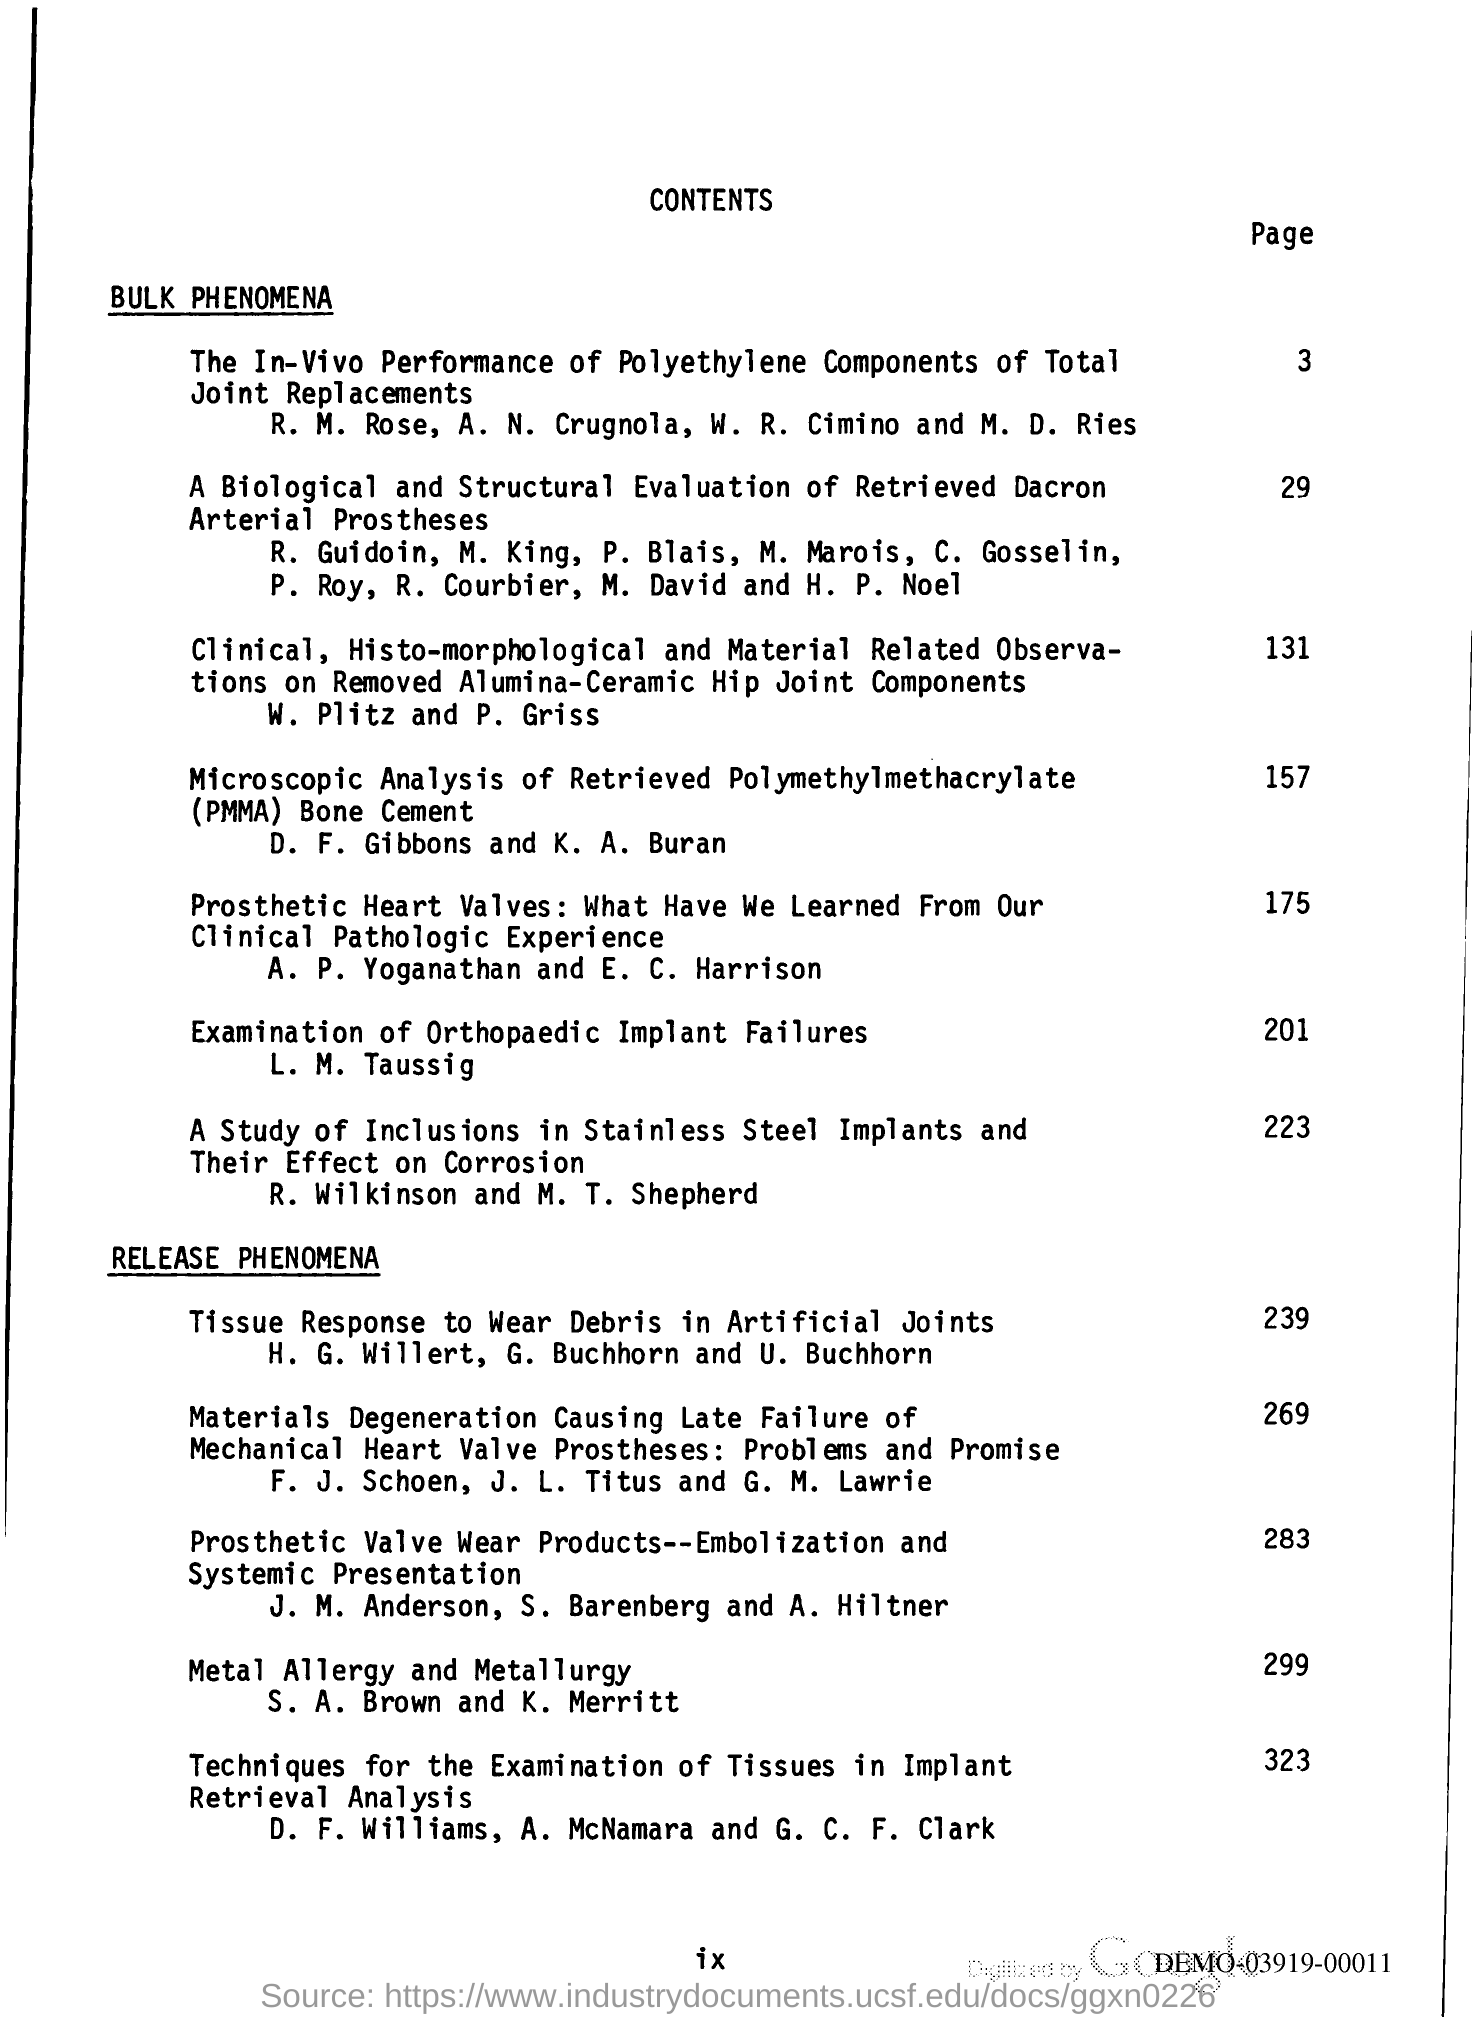What is the page number at which prosthetic heart valves is located?
Provide a short and direct response. 175. Release phenomena starts from which page number?
Offer a terse response. 239. 